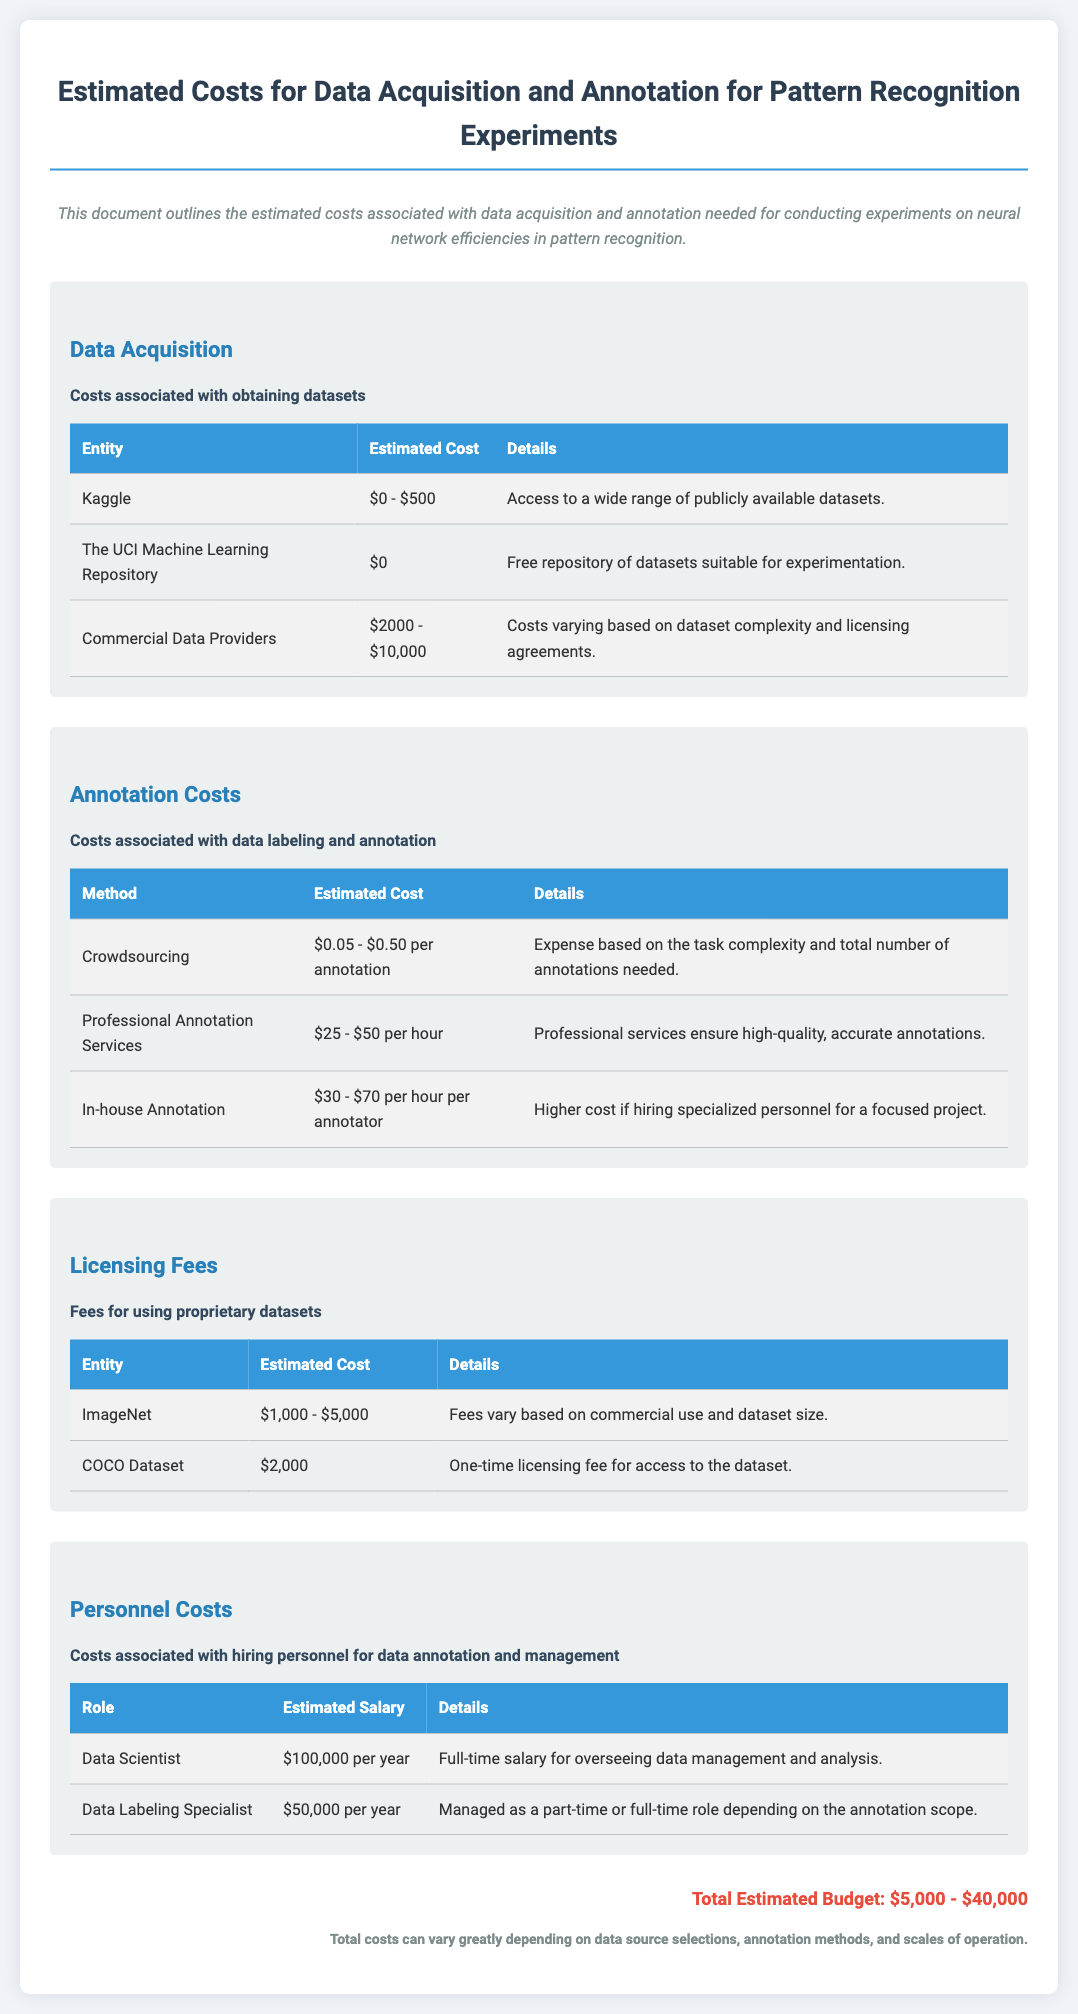What is the estimated cost range for acquiring datasets from Kaggle? The estimated cost range for Kaggle is mentioned as $0 - $500 in the document.
Answer: $0 - $500 What is the cost of using the COCO Dataset? The document states that the licensing fee for the COCO Dataset is a one-time fee of $2,000.
Answer: $2,000 How much does a Data Scientist earn per year according to the budget? The document specifies that a Data Scientist earns $100,000 per year.
Answer: $100,000 What is the cost per annotation for crowdsourcing? The budget indicates that crowdsourcing costs $0.05 - $0.50 per annotation.
Answer: $0.05 - $0.50 Which method has the highest cost per hour for annotation? The highest cost per hour for annotation according to the document is for in-house annotation at $30 - $70 per hour per annotator.
Answer: $30 - $70 per hour per annotator What are the total estimated budget costs mentioned in the document? The total estimated budget costs range from $5,000 to $40,000.
Answer: $5,000 - $40,000 What type of data repositories does the UCI Machine Learning Repository belong to? It is a free repository of datasets suitable for experimentation as noted in the document.
Answer: Free repository What is the cost range for licensing fees for ImageNet? The document states that the fees for ImageNet vary from $1,000 to $5,000.
Answer: $1,000 - $5,000 What role is managed as a part-time or full-time position depending on annotation scope? The role of Data Labeling Specialist is managed as a part-time or full-time position.
Answer: Data Labeling Specialist 